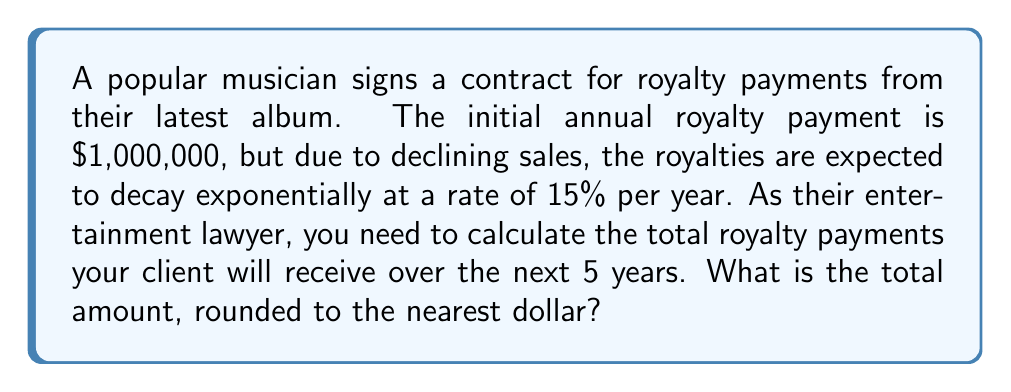Can you answer this question? Let's approach this step-by-step:

1) The initial payment is $1,000,000, and it decays at a rate of 15% per year.

2) We can model this with the exponential decay formula:
   $$A(t) = A_0(1-r)^t$$
   where $A(t)$ is the amount at time $t$, $A_0$ is the initial amount, $r$ is the decay rate, and $t$ is the time in years.

3) In this case, $A_0 = 1,000,000$, $r = 0.15$, and we need to calculate for $t = 0, 1, 2, 3, 4, 5$.

4) Let's calculate the royalties for each year:

   Year 0: $A(0) = 1,000,000(1-0.15)^0 = 1,000,000$
   Year 1: $A(1) = 1,000,000(1-0.15)^1 = 850,000$
   Year 2: $A(2) = 1,000,000(1-0.15)^2 = 722,500$
   Year 3: $A(3) = 1,000,000(1-0.15)^3 = 614,125$
   Year 4: $A(4) = 1,000,000(1-0.15)^4 = 522,006.25$
   Year 5: $A(5) = 1,000,000(1-0.15)^5 = 443,705.31$

5) To get the total, we sum all these values:

   $$\text{Total} = 1,000,000 + 850,000 + 722,500 + 614,125 + 522,006.25 + 443,705.31$$

6) This sum equals $4,152,336.56$

7) Rounding to the nearest dollar gives us $4,152,337$.
Answer: $4,152,337 